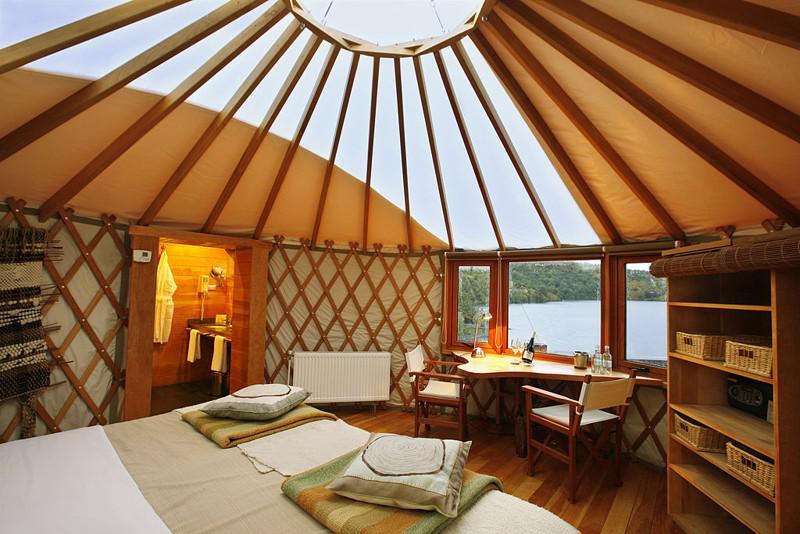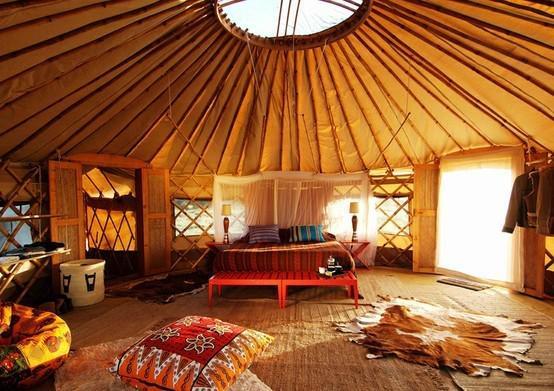The first image is the image on the left, the second image is the image on the right. For the images displayed, is the sentence "At least one room has a patterned oriental-type rug on the floor." factually correct? Answer yes or no. No. 